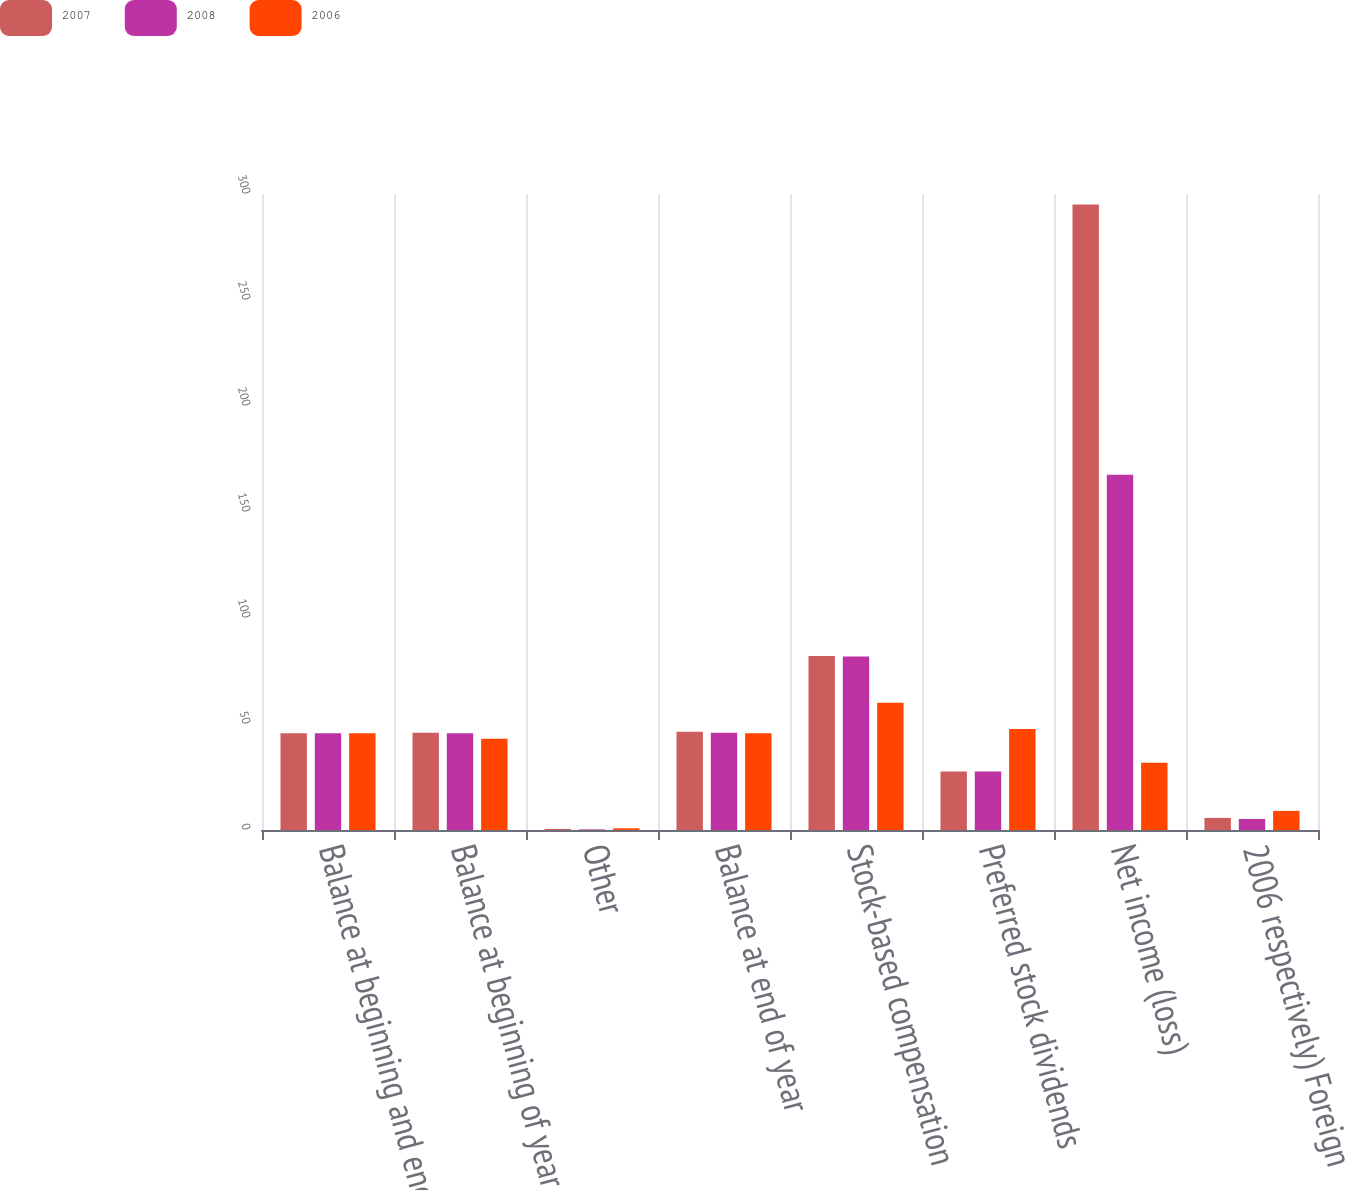<chart> <loc_0><loc_0><loc_500><loc_500><stacked_bar_chart><ecel><fcel>Balance at beginning and end<fcel>Balance at beginning of year<fcel>Other<fcel>Balance at end of year<fcel>Stock-based compensation<fcel>Preferred stock dividends<fcel>Net income (loss)<fcel>2006 respectively) Foreign<nl><fcel>2007<fcel>45.6<fcel>45.9<fcel>0.5<fcel>46.4<fcel>82.1<fcel>27.6<fcel>295<fcel>5.7<nl><fcel>2008<fcel>45.6<fcel>45.6<fcel>0.3<fcel>45.9<fcel>81.8<fcel>27.6<fcel>167.6<fcel>5.2<nl><fcel>2006<fcel>45.6<fcel>43<fcel>0.8<fcel>45.6<fcel>60<fcel>47.6<fcel>31.7<fcel>9<nl></chart> 